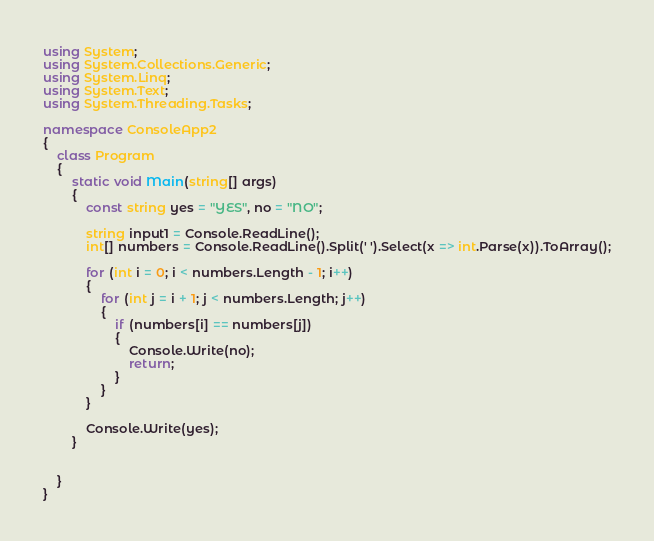Convert code to text. <code><loc_0><loc_0><loc_500><loc_500><_C#_>using System;
using System.Collections.Generic;
using System.Linq;
using System.Text;
using System.Threading.Tasks;

namespace ConsoleApp2
{
    class Program
    {
        static void Main(string[] args)
        {
            const string yes = "YES", no = "NO";

            string input1 = Console.ReadLine();
            int[] numbers = Console.ReadLine().Split(' ').Select(x => int.Parse(x)).ToArray();

            for (int i = 0; i < numbers.Length - 1; i++)
            {
                for (int j = i + 1; j < numbers.Length; j++)
                {
                    if (numbers[i] == numbers[j])
                    {
                        Console.Write(no);
                        return;
                    }
                }
            }

            Console.Write(yes);
        }


    }
}</code> 